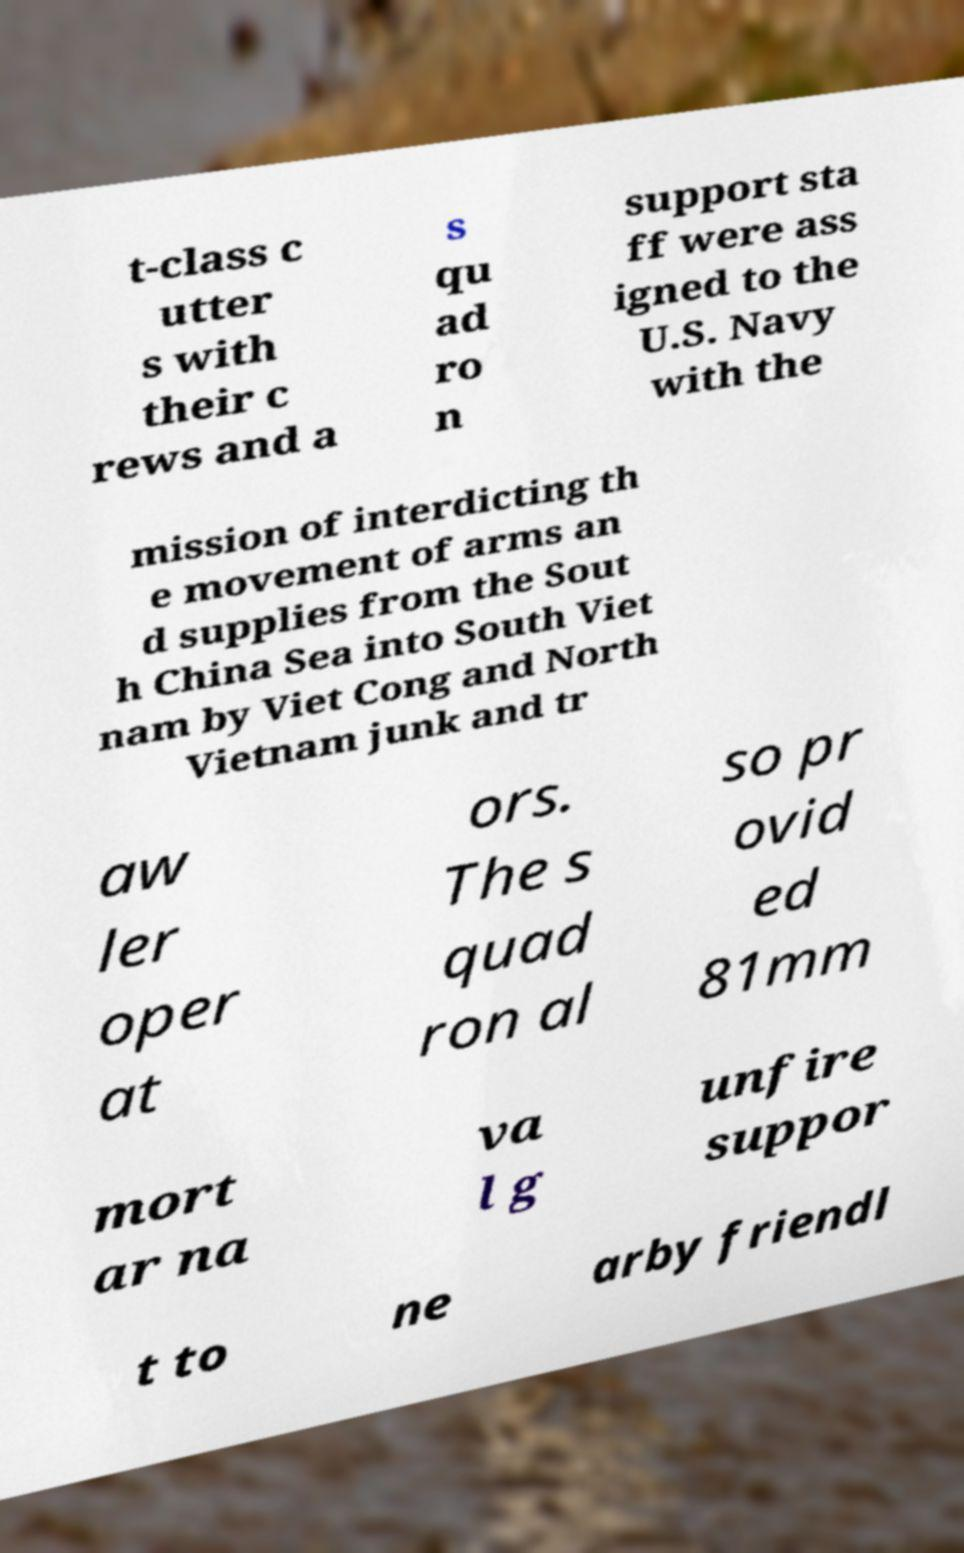There's text embedded in this image that I need extracted. Can you transcribe it verbatim? t-class c utter s with their c rews and a s qu ad ro n support sta ff were ass igned to the U.S. Navy with the mission of interdicting th e movement of arms an d supplies from the Sout h China Sea into South Viet nam by Viet Cong and North Vietnam junk and tr aw ler oper at ors. The s quad ron al so pr ovid ed 81mm mort ar na va l g unfire suppor t to ne arby friendl 